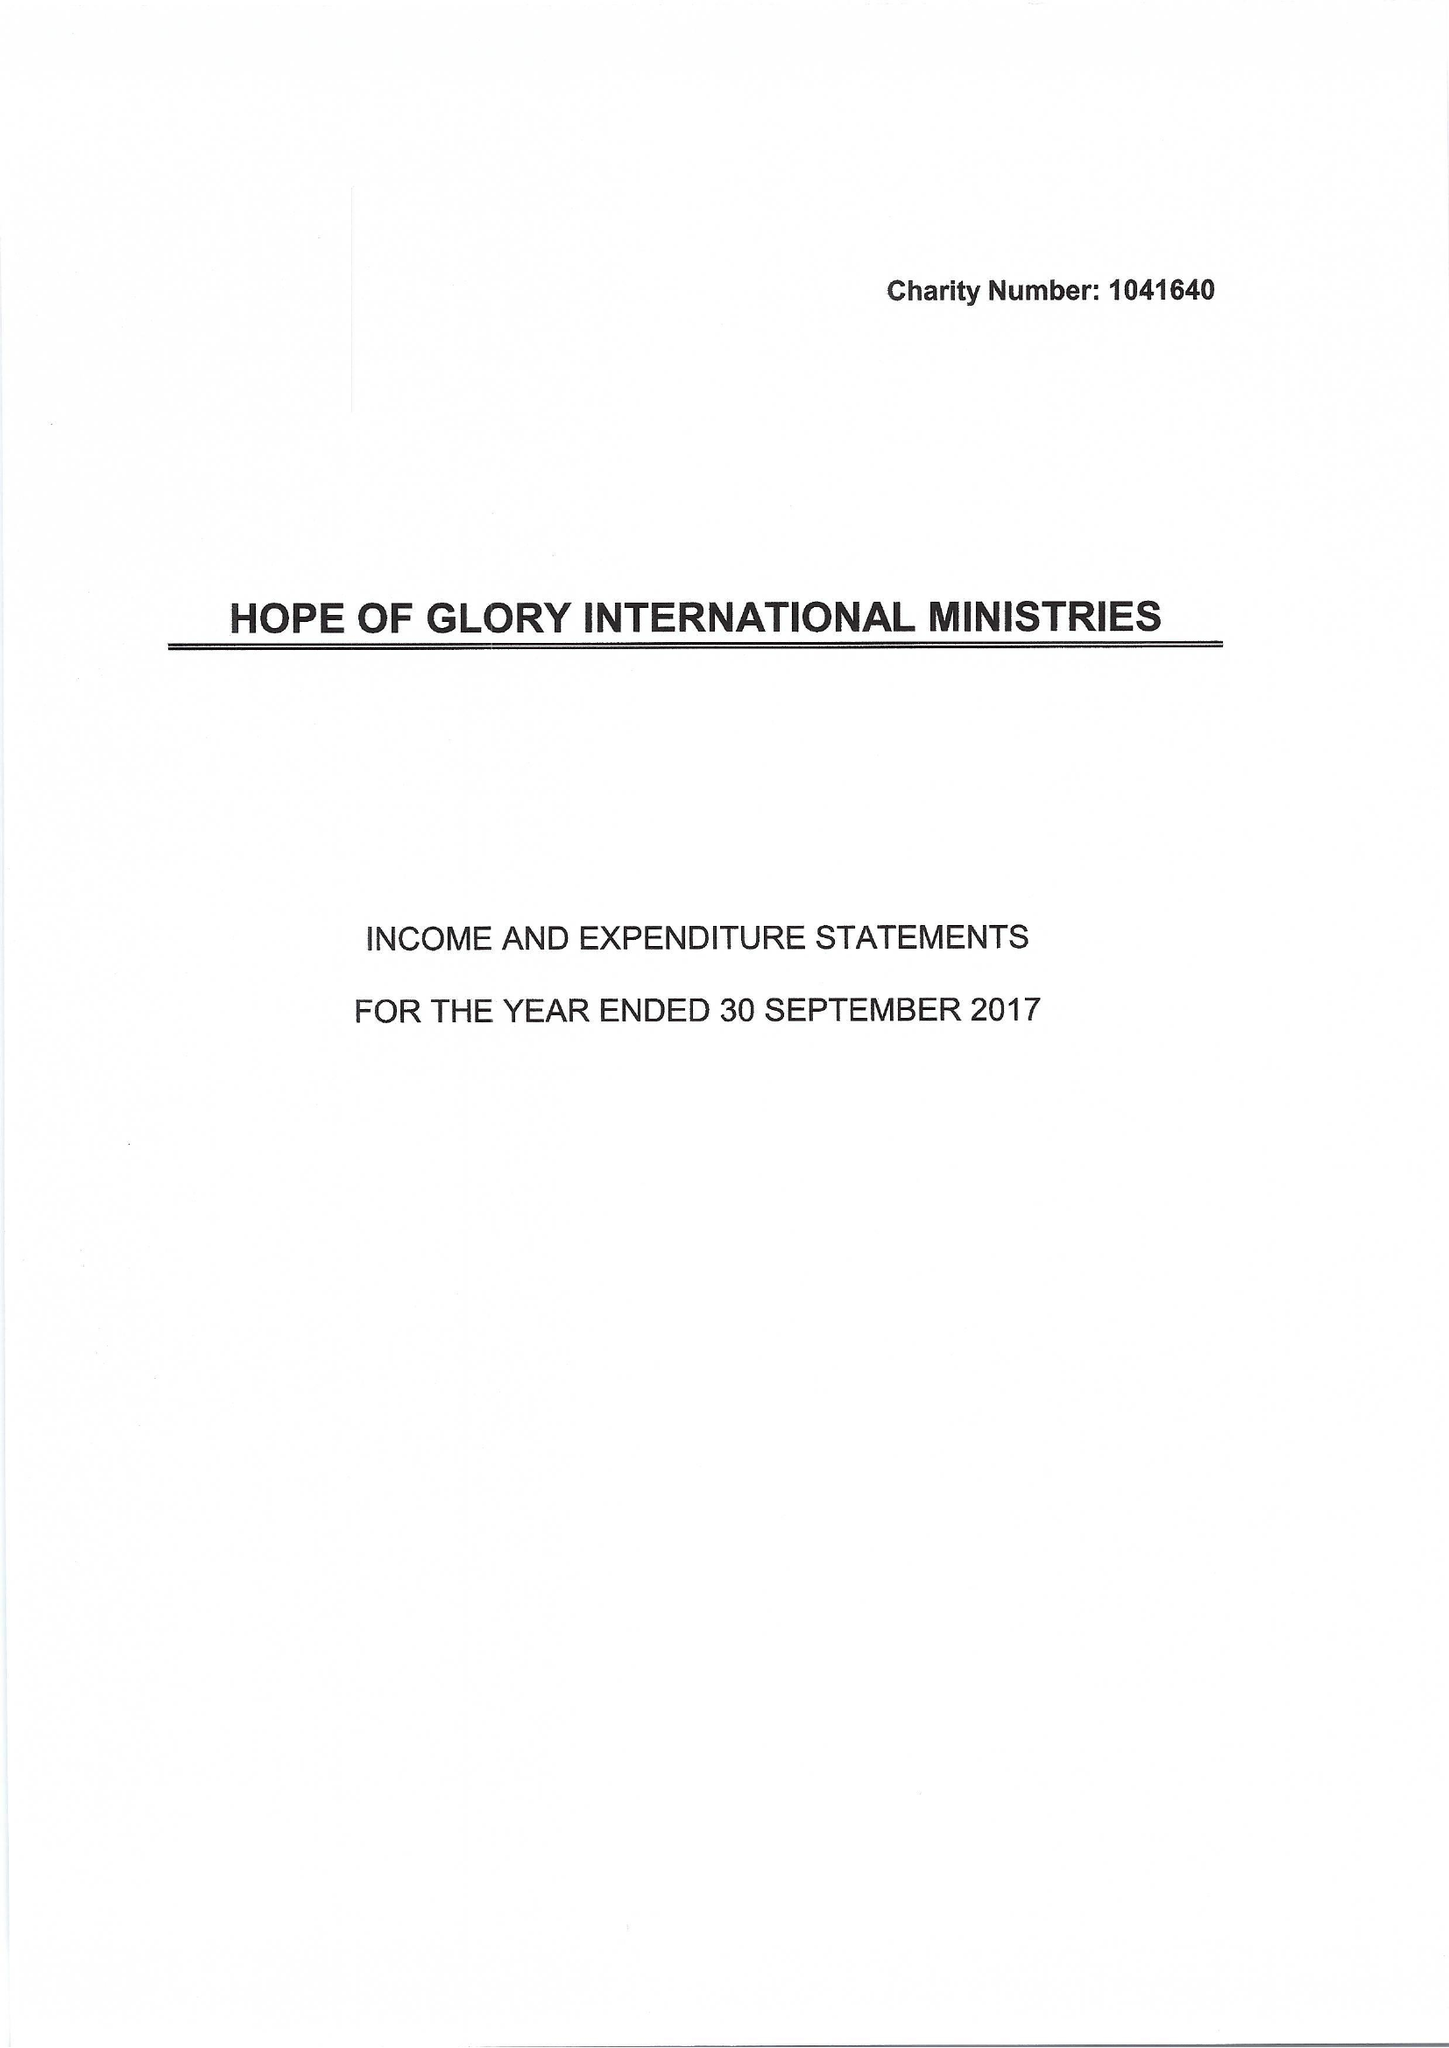What is the value for the report_date?
Answer the question using a single word or phrase. 2017-09-30 